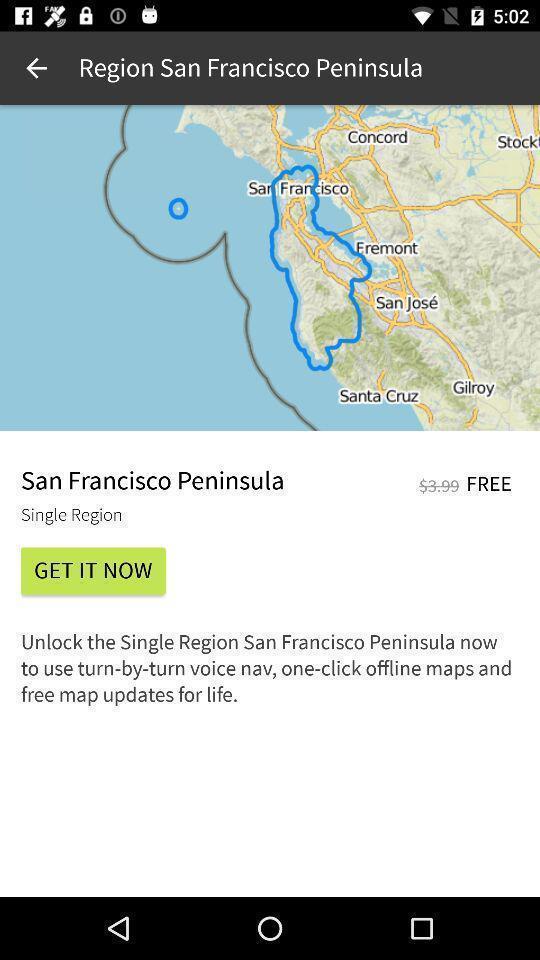Tell me what you see in this picture. Page displays unlock the region in app. 